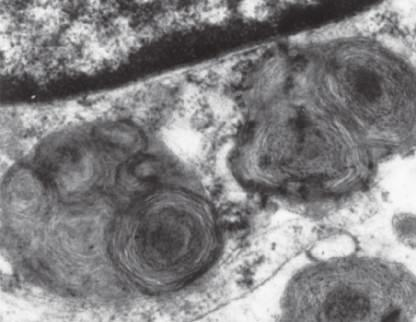what shows prominent lysosomes with whorled configurations just below part of the nucleus?
Answer the question using a single word or phrase. A portion of a neuron under the electron microscope 